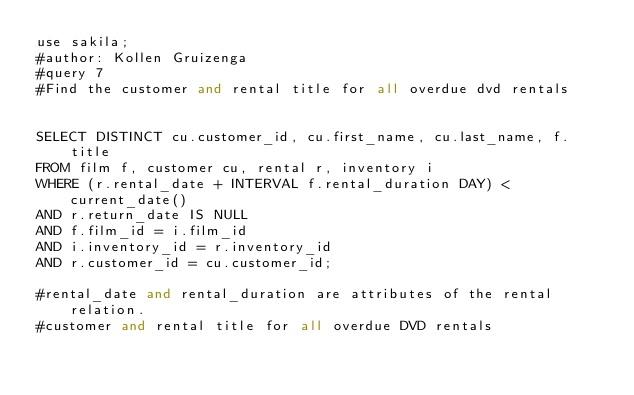<code> <loc_0><loc_0><loc_500><loc_500><_SQL_>use sakila;
#author: Kollen Gruizenga
#query 7
#Find the customer and rental title for all overdue dvd rentals


SELECT DISTINCT cu.customer_id, cu.first_name, cu.last_name, f.title
FROM film f, customer cu, rental r, inventory i
WHERE (r.rental_date + INTERVAL f.rental_duration DAY) < current_date()
AND r.return_date IS NULL
AND f.film_id = i.film_id
AND i.inventory_id = r.inventory_id
AND r.customer_id = cu.customer_id;

#rental_date and rental_duration are attributes of the rental relation.
#customer and rental title for all overdue DVD rentals</code> 